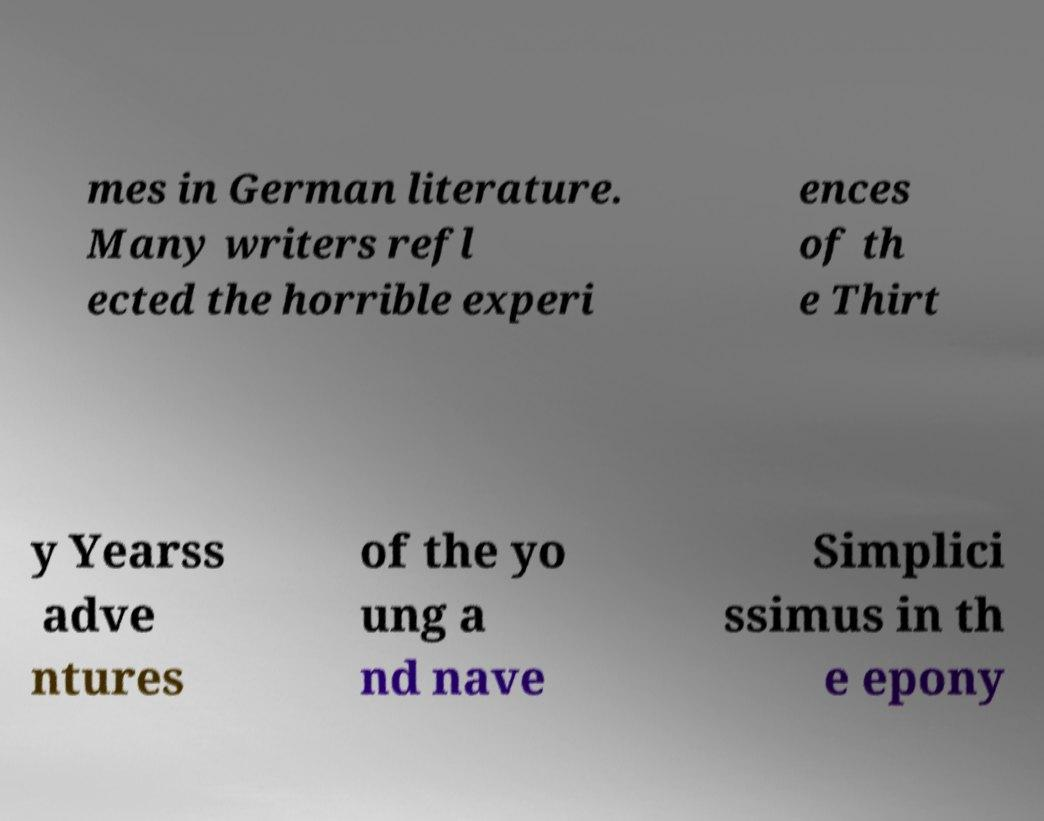There's text embedded in this image that I need extracted. Can you transcribe it verbatim? mes in German literature. Many writers refl ected the horrible experi ences of th e Thirt y Yearss adve ntures of the yo ung a nd nave Simplici ssimus in th e epony 